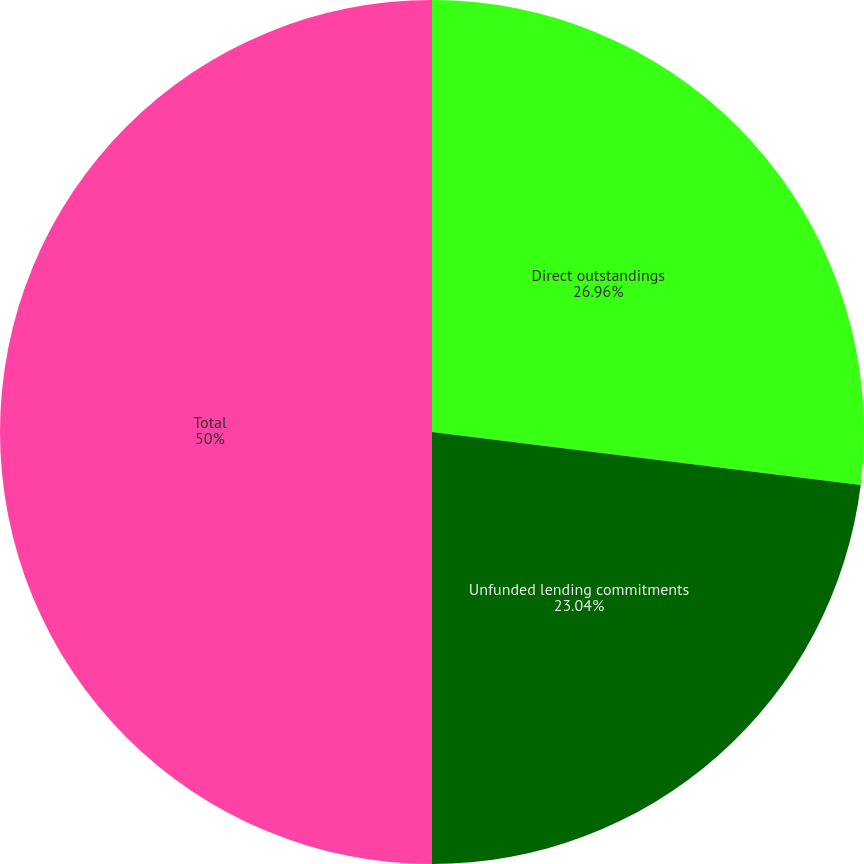Convert chart. <chart><loc_0><loc_0><loc_500><loc_500><pie_chart><fcel>Direct outstandings<fcel>Unfunded lending commitments<fcel>Total<nl><fcel>26.96%<fcel>23.04%<fcel>50.0%<nl></chart> 